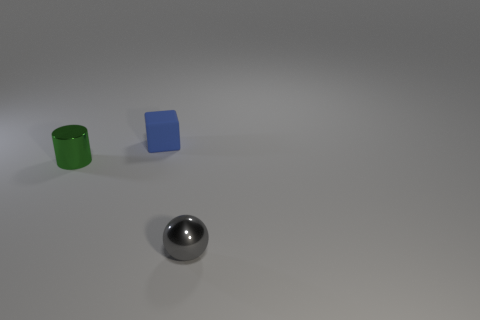Add 3 purple cubes. How many objects exist? 6 Subtract all cylinders. How many objects are left? 2 Add 3 tiny blue rubber cubes. How many tiny blue rubber cubes are left? 4 Add 3 green objects. How many green objects exist? 4 Subtract 0 cyan cubes. How many objects are left? 3 Subtract all tiny blue metallic cylinders. Subtract all shiny objects. How many objects are left? 1 